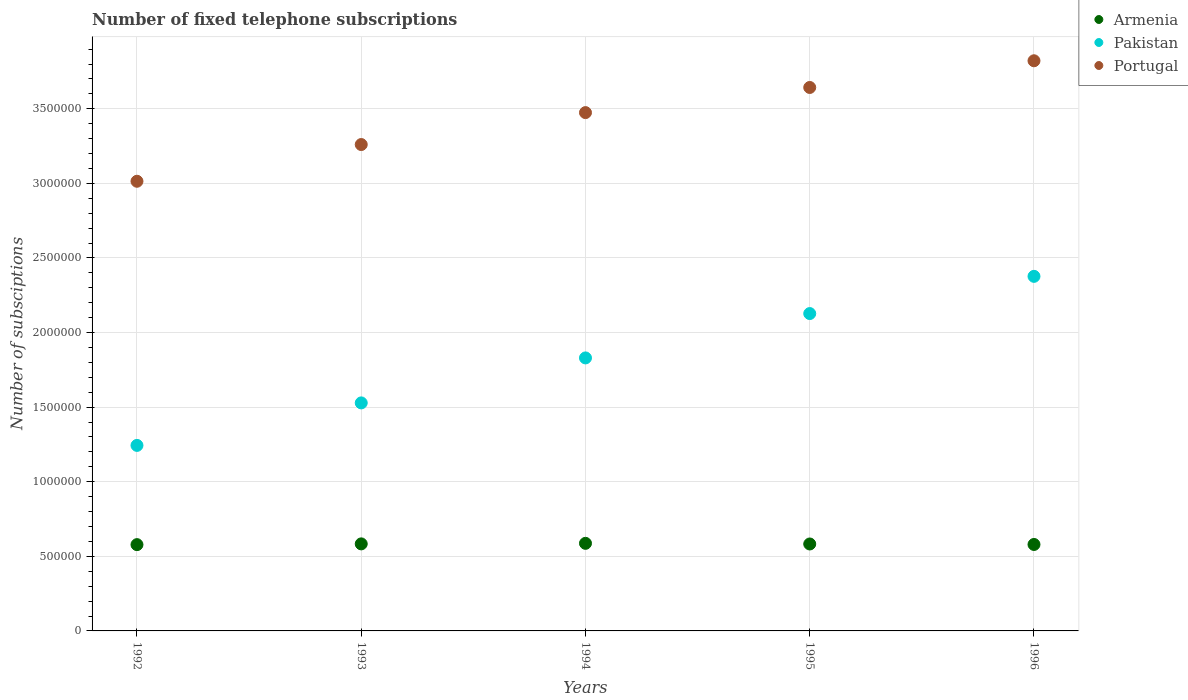How many different coloured dotlines are there?
Provide a short and direct response. 3. What is the number of fixed telephone subscriptions in Armenia in 1993?
Your response must be concise. 5.83e+05. Across all years, what is the maximum number of fixed telephone subscriptions in Armenia?
Offer a terse response. 5.87e+05. Across all years, what is the minimum number of fixed telephone subscriptions in Pakistan?
Your answer should be very brief. 1.24e+06. In which year was the number of fixed telephone subscriptions in Armenia minimum?
Provide a succinct answer. 1992. What is the total number of fixed telephone subscriptions in Pakistan in the graph?
Offer a very short reply. 9.11e+06. What is the difference between the number of fixed telephone subscriptions in Pakistan in 1993 and that in 1995?
Your answer should be very brief. -5.99e+05. What is the difference between the number of fixed telephone subscriptions in Pakistan in 1992 and the number of fixed telephone subscriptions in Armenia in 1996?
Provide a succinct answer. 6.64e+05. What is the average number of fixed telephone subscriptions in Pakistan per year?
Make the answer very short. 1.82e+06. In the year 1993, what is the difference between the number of fixed telephone subscriptions in Portugal and number of fixed telephone subscriptions in Pakistan?
Keep it short and to the point. 1.73e+06. What is the ratio of the number of fixed telephone subscriptions in Armenia in 1994 to that in 1996?
Your answer should be compact. 1.01. Is the number of fixed telephone subscriptions in Armenia in 1993 less than that in 1995?
Offer a terse response. No. What is the difference between the highest and the second highest number of fixed telephone subscriptions in Armenia?
Your answer should be compact. 3653. What is the difference between the highest and the lowest number of fixed telephone subscriptions in Armenia?
Your answer should be compact. 8713. In how many years, is the number of fixed telephone subscriptions in Portugal greater than the average number of fixed telephone subscriptions in Portugal taken over all years?
Provide a succinct answer. 3. Is it the case that in every year, the sum of the number of fixed telephone subscriptions in Portugal and number of fixed telephone subscriptions in Pakistan  is greater than the number of fixed telephone subscriptions in Armenia?
Ensure brevity in your answer.  Yes. Is the number of fixed telephone subscriptions in Armenia strictly greater than the number of fixed telephone subscriptions in Pakistan over the years?
Your answer should be compact. No. Is the number of fixed telephone subscriptions in Portugal strictly less than the number of fixed telephone subscriptions in Armenia over the years?
Ensure brevity in your answer.  No. How many dotlines are there?
Offer a terse response. 3. Are the values on the major ticks of Y-axis written in scientific E-notation?
Your answer should be very brief. No. How many legend labels are there?
Offer a very short reply. 3. What is the title of the graph?
Ensure brevity in your answer.  Number of fixed telephone subscriptions. What is the label or title of the Y-axis?
Give a very brief answer. Number of subsciptions. What is the Number of subsciptions of Armenia in 1992?
Offer a terse response. 5.78e+05. What is the Number of subsciptions of Pakistan in 1992?
Make the answer very short. 1.24e+06. What is the Number of subsciptions in Portugal in 1992?
Provide a succinct answer. 3.01e+06. What is the Number of subsciptions in Armenia in 1993?
Your answer should be compact. 5.83e+05. What is the Number of subsciptions of Pakistan in 1993?
Offer a terse response. 1.53e+06. What is the Number of subsciptions in Portugal in 1993?
Give a very brief answer. 3.26e+06. What is the Number of subsciptions in Armenia in 1994?
Make the answer very short. 5.87e+05. What is the Number of subsciptions in Pakistan in 1994?
Keep it short and to the point. 1.83e+06. What is the Number of subsciptions in Portugal in 1994?
Ensure brevity in your answer.  3.47e+06. What is the Number of subsciptions of Armenia in 1995?
Your answer should be very brief. 5.83e+05. What is the Number of subsciptions in Pakistan in 1995?
Provide a succinct answer. 2.13e+06. What is the Number of subsciptions of Portugal in 1995?
Your response must be concise. 3.64e+06. What is the Number of subsciptions in Armenia in 1996?
Offer a terse response. 5.80e+05. What is the Number of subsciptions in Pakistan in 1996?
Give a very brief answer. 2.38e+06. What is the Number of subsciptions of Portugal in 1996?
Keep it short and to the point. 3.82e+06. Across all years, what is the maximum Number of subsciptions of Armenia?
Keep it short and to the point. 5.87e+05. Across all years, what is the maximum Number of subsciptions of Pakistan?
Offer a terse response. 2.38e+06. Across all years, what is the maximum Number of subsciptions in Portugal?
Keep it short and to the point. 3.82e+06. Across all years, what is the minimum Number of subsciptions in Armenia?
Your answer should be compact. 5.78e+05. Across all years, what is the minimum Number of subsciptions in Pakistan?
Ensure brevity in your answer.  1.24e+06. Across all years, what is the minimum Number of subsciptions in Portugal?
Offer a terse response. 3.01e+06. What is the total Number of subsciptions in Armenia in the graph?
Provide a short and direct response. 2.91e+06. What is the total Number of subsciptions in Pakistan in the graph?
Offer a very short reply. 9.11e+06. What is the total Number of subsciptions in Portugal in the graph?
Your response must be concise. 1.72e+07. What is the difference between the Number of subsciptions of Armenia in 1992 and that in 1993?
Provide a succinct answer. -5060. What is the difference between the Number of subsciptions of Pakistan in 1992 and that in 1993?
Your response must be concise. -2.85e+05. What is the difference between the Number of subsciptions of Portugal in 1992 and that in 1993?
Your answer should be compact. -2.46e+05. What is the difference between the Number of subsciptions of Armenia in 1992 and that in 1994?
Offer a terse response. -8713. What is the difference between the Number of subsciptions in Pakistan in 1992 and that in 1994?
Your answer should be compact. -5.86e+05. What is the difference between the Number of subsciptions of Portugal in 1992 and that in 1994?
Keep it short and to the point. -4.60e+05. What is the difference between the Number of subsciptions in Armenia in 1992 and that in 1995?
Offer a very short reply. -4400. What is the difference between the Number of subsciptions in Pakistan in 1992 and that in 1995?
Your answer should be compact. -8.84e+05. What is the difference between the Number of subsciptions in Portugal in 1992 and that in 1995?
Your response must be concise. -6.29e+05. What is the difference between the Number of subsciptions in Armenia in 1992 and that in 1996?
Your answer should be compact. -1100. What is the difference between the Number of subsciptions in Pakistan in 1992 and that in 1996?
Offer a terse response. -1.13e+06. What is the difference between the Number of subsciptions of Portugal in 1992 and that in 1996?
Provide a succinct answer. -8.08e+05. What is the difference between the Number of subsciptions of Armenia in 1993 and that in 1994?
Your response must be concise. -3653. What is the difference between the Number of subsciptions of Pakistan in 1993 and that in 1994?
Your response must be concise. -3.02e+05. What is the difference between the Number of subsciptions in Portugal in 1993 and that in 1994?
Your answer should be compact. -2.14e+05. What is the difference between the Number of subsciptions in Armenia in 1993 and that in 1995?
Offer a terse response. 660. What is the difference between the Number of subsciptions of Pakistan in 1993 and that in 1995?
Ensure brevity in your answer.  -5.99e+05. What is the difference between the Number of subsciptions in Portugal in 1993 and that in 1995?
Make the answer very short. -3.83e+05. What is the difference between the Number of subsciptions of Armenia in 1993 and that in 1996?
Ensure brevity in your answer.  3960. What is the difference between the Number of subsciptions of Pakistan in 1993 and that in 1996?
Keep it short and to the point. -8.48e+05. What is the difference between the Number of subsciptions of Portugal in 1993 and that in 1996?
Provide a short and direct response. -5.62e+05. What is the difference between the Number of subsciptions of Armenia in 1994 and that in 1995?
Keep it short and to the point. 4313. What is the difference between the Number of subsciptions in Pakistan in 1994 and that in 1995?
Your answer should be very brief. -2.97e+05. What is the difference between the Number of subsciptions in Portugal in 1994 and that in 1995?
Keep it short and to the point. -1.68e+05. What is the difference between the Number of subsciptions in Armenia in 1994 and that in 1996?
Keep it short and to the point. 7613. What is the difference between the Number of subsciptions in Pakistan in 1994 and that in 1996?
Make the answer very short. -5.47e+05. What is the difference between the Number of subsciptions of Portugal in 1994 and that in 1996?
Keep it short and to the point. -3.47e+05. What is the difference between the Number of subsciptions of Armenia in 1995 and that in 1996?
Your answer should be very brief. 3300. What is the difference between the Number of subsciptions of Pakistan in 1995 and that in 1996?
Offer a terse response. -2.49e+05. What is the difference between the Number of subsciptions of Portugal in 1995 and that in 1996?
Make the answer very short. -1.79e+05. What is the difference between the Number of subsciptions of Armenia in 1992 and the Number of subsciptions of Pakistan in 1993?
Your answer should be compact. -9.50e+05. What is the difference between the Number of subsciptions of Armenia in 1992 and the Number of subsciptions of Portugal in 1993?
Offer a terse response. -2.68e+06. What is the difference between the Number of subsciptions in Pakistan in 1992 and the Number of subsciptions in Portugal in 1993?
Offer a very short reply. -2.02e+06. What is the difference between the Number of subsciptions in Armenia in 1992 and the Number of subsciptions in Pakistan in 1994?
Keep it short and to the point. -1.25e+06. What is the difference between the Number of subsciptions in Armenia in 1992 and the Number of subsciptions in Portugal in 1994?
Give a very brief answer. -2.90e+06. What is the difference between the Number of subsciptions of Pakistan in 1992 and the Number of subsciptions of Portugal in 1994?
Provide a succinct answer. -2.23e+06. What is the difference between the Number of subsciptions of Armenia in 1992 and the Number of subsciptions of Pakistan in 1995?
Provide a short and direct response. -1.55e+06. What is the difference between the Number of subsciptions in Armenia in 1992 and the Number of subsciptions in Portugal in 1995?
Your answer should be compact. -3.06e+06. What is the difference between the Number of subsciptions of Pakistan in 1992 and the Number of subsciptions of Portugal in 1995?
Provide a short and direct response. -2.40e+06. What is the difference between the Number of subsciptions of Armenia in 1992 and the Number of subsciptions of Pakistan in 1996?
Your answer should be very brief. -1.80e+06. What is the difference between the Number of subsciptions of Armenia in 1992 and the Number of subsciptions of Portugal in 1996?
Give a very brief answer. -3.24e+06. What is the difference between the Number of subsciptions in Pakistan in 1992 and the Number of subsciptions in Portugal in 1996?
Your response must be concise. -2.58e+06. What is the difference between the Number of subsciptions of Armenia in 1993 and the Number of subsciptions of Pakistan in 1994?
Your answer should be very brief. -1.25e+06. What is the difference between the Number of subsciptions of Armenia in 1993 and the Number of subsciptions of Portugal in 1994?
Give a very brief answer. -2.89e+06. What is the difference between the Number of subsciptions of Pakistan in 1993 and the Number of subsciptions of Portugal in 1994?
Offer a very short reply. -1.95e+06. What is the difference between the Number of subsciptions in Armenia in 1993 and the Number of subsciptions in Pakistan in 1995?
Provide a short and direct response. -1.54e+06. What is the difference between the Number of subsciptions of Armenia in 1993 and the Number of subsciptions of Portugal in 1995?
Provide a short and direct response. -3.06e+06. What is the difference between the Number of subsciptions of Pakistan in 1993 and the Number of subsciptions of Portugal in 1995?
Give a very brief answer. -2.11e+06. What is the difference between the Number of subsciptions in Armenia in 1993 and the Number of subsciptions in Pakistan in 1996?
Offer a terse response. -1.79e+06. What is the difference between the Number of subsciptions of Armenia in 1993 and the Number of subsciptions of Portugal in 1996?
Your response must be concise. -3.24e+06. What is the difference between the Number of subsciptions of Pakistan in 1993 and the Number of subsciptions of Portugal in 1996?
Give a very brief answer. -2.29e+06. What is the difference between the Number of subsciptions of Armenia in 1994 and the Number of subsciptions of Pakistan in 1995?
Make the answer very short. -1.54e+06. What is the difference between the Number of subsciptions of Armenia in 1994 and the Number of subsciptions of Portugal in 1995?
Offer a terse response. -3.06e+06. What is the difference between the Number of subsciptions in Pakistan in 1994 and the Number of subsciptions in Portugal in 1995?
Your answer should be compact. -1.81e+06. What is the difference between the Number of subsciptions in Armenia in 1994 and the Number of subsciptions in Pakistan in 1996?
Your answer should be very brief. -1.79e+06. What is the difference between the Number of subsciptions in Armenia in 1994 and the Number of subsciptions in Portugal in 1996?
Give a very brief answer. -3.23e+06. What is the difference between the Number of subsciptions of Pakistan in 1994 and the Number of subsciptions of Portugal in 1996?
Keep it short and to the point. -1.99e+06. What is the difference between the Number of subsciptions in Armenia in 1995 and the Number of subsciptions in Pakistan in 1996?
Your answer should be very brief. -1.79e+06. What is the difference between the Number of subsciptions of Armenia in 1995 and the Number of subsciptions of Portugal in 1996?
Your response must be concise. -3.24e+06. What is the difference between the Number of subsciptions of Pakistan in 1995 and the Number of subsciptions of Portugal in 1996?
Offer a terse response. -1.69e+06. What is the average Number of subsciptions of Armenia per year?
Make the answer very short. 5.82e+05. What is the average Number of subsciptions in Pakistan per year?
Make the answer very short. 1.82e+06. What is the average Number of subsciptions of Portugal per year?
Keep it short and to the point. 3.44e+06. In the year 1992, what is the difference between the Number of subsciptions in Armenia and Number of subsciptions in Pakistan?
Make the answer very short. -6.65e+05. In the year 1992, what is the difference between the Number of subsciptions in Armenia and Number of subsciptions in Portugal?
Ensure brevity in your answer.  -2.44e+06. In the year 1992, what is the difference between the Number of subsciptions of Pakistan and Number of subsciptions of Portugal?
Keep it short and to the point. -1.77e+06. In the year 1993, what is the difference between the Number of subsciptions of Armenia and Number of subsciptions of Pakistan?
Provide a short and direct response. -9.45e+05. In the year 1993, what is the difference between the Number of subsciptions in Armenia and Number of subsciptions in Portugal?
Your response must be concise. -2.68e+06. In the year 1993, what is the difference between the Number of subsciptions in Pakistan and Number of subsciptions in Portugal?
Provide a succinct answer. -1.73e+06. In the year 1994, what is the difference between the Number of subsciptions of Armenia and Number of subsciptions of Pakistan?
Provide a succinct answer. -1.24e+06. In the year 1994, what is the difference between the Number of subsciptions in Armenia and Number of subsciptions in Portugal?
Provide a succinct answer. -2.89e+06. In the year 1994, what is the difference between the Number of subsciptions in Pakistan and Number of subsciptions in Portugal?
Offer a very short reply. -1.64e+06. In the year 1995, what is the difference between the Number of subsciptions in Armenia and Number of subsciptions in Pakistan?
Provide a short and direct response. -1.54e+06. In the year 1995, what is the difference between the Number of subsciptions in Armenia and Number of subsciptions in Portugal?
Offer a terse response. -3.06e+06. In the year 1995, what is the difference between the Number of subsciptions in Pakistan and Number of subsciptions in Portugal?
Your response must be concise. -1.52e+06. In the year 1996, what is the difference between the Number of subsciptions of Armenia and Number of subsciptions of Pakistan?
Keep it short and to the point. -1.80e+06. In the year 1996, what is the difference between the Number of subsciptions of Armenia and Number of subsciptions of Portugal?
Offer a terse response. -3.24e+06. In the year 1996, what is the difference between the Number of subsciptions of Pakistan and Number of subsciptions of Portugal?
Your answer should be compact. -1.45e+06. What is the ratio of the Number of subsciptions of Armenia in 1992 to that in 1993?
Offer a terse response. 0.99. What is the ratio of the Number of subsciptions in Pakistan in 1992 to that in 1993?
Offer a terse response. 0.81. What is the ratio of the Number of subsciptions in Portugal in 1992 to that in 1993?
Ensure brevity in your answer.  0.92. What is the ratio of the Number of subsciptions of Armenia in 1992 to that in 1994?
Provide a succinct answer. 0.99. What is the ratio of the Number of subsciptions in Pakistan in 1992 to that in 1994?
Your answer should be very brief. 0.68. What is the ratio of the Number of subsciptions of Portugal in 1992 to that in 1994?
Your answer should be very brief. 0.87. What is the ratio of the Number of subsciptions of Pakistan in 1992 to that in 1995?
Make the answer very short. 0.58. What is the ratio of the Number of subsciptions of Portugal in 1992 to that in 1995?
Provide a short and direct response. 0.83. What is the ratio of the Number of subsciptions in Armenia in 1992 to that in 1996?
Provide a short and direct response. 1. What is the ratio of the Number of subsciptions of Pakistan in 1992 to that in 1996?
Give a very brief answer. 0.52. What is the ratio of the Number of subsciptions of Portugal in 1992 to that in 1996?
Make the answer very short. 0.79. What is the ratio of the Number of subsciptions of Armenia in 1993 to that in 1994?
Your answer should be compact. 0.99. What is the ratio of the Number of subsciptions in Pakistan in 1993 to that in 1994?
Provide a succinct answer. 0.84. What is the ratio of the Number of subsciptions of Portugal in 1993 to that in 1994?
Make the answer very short. 0.94. What is the ratio of the Number of subsciptions of Pakistan in 1993 to that in 1995?
Make the answer very short. 0.72. What is the ratio of the Number of subsciptions of Portugal in 1993 to that in 1995?
Give a very brief answer. 0.9. What is the ratio of the Number of subsciptions in Armenia in 1993 to that in 1996?
Keep it short and to the point. 1.01. What is the ratio of the Number of subsciptions of Pakistan in 1993 to that in 1996?
Your answer should be very brief. 0.64. What is the ratio of the Number of subsciptions in Portugal in 1993 to that in 1996?
Your answer should be compact. 0.85. What is the ratio of the Number of subsciptions of Armenia in 1994 to that in 1995?
Your response must be concise. 1.01. What is the ratio of the Number of subsciptions of Pakistan in 1994 to that in 1995?
Provide a succinct answer. 0.86. What is the ratio of the Number of subsciptions of Portugal in 1994 to that in 1995?
Your answer should be very brief. 0.95. What is the ratio of the Number of subsciptions in Armenia in 1994 to that in 1996?
Offer a very short reply. 1.01. What is the ratio of the Number of subsciptions of Pakistan in 1994 to that in 1996?
Make the answer very short. 0.77. What is the ratio of the Number of subsciptions of Pakistan in 1995 to that in 1996?
Give a very brief answer. 0.9. What is the ratio of the Number of subsciptions of Portugal in 1995 to that in 1996?
Your answer should be very brief. 0.95. What is the difference between the highest and the second highest Number of subsciptions in Armenia?
Give a very brief answer. 3653. What is the difference between the highest and the second highest Number of subsciptions in Pakistan?
Make the answer very short. 2.49e+05. What is the difference between the highest and the second highest Number of subsciptions of Portugal?
Your response must be concise. 1.79e+05. What is the difference between the highest and the lowest Number of subsciptions in Armenia?
Keep it short and to the point. 8713. What is the difference between the highest and the lowest Number of subsciptions of Pakistan?
Your response must be concise. 1.13e+06. What is the difference between the highest and the lowest Number of subsciptions of Portugal?
Offer a very short reply. 8.08e+05. 